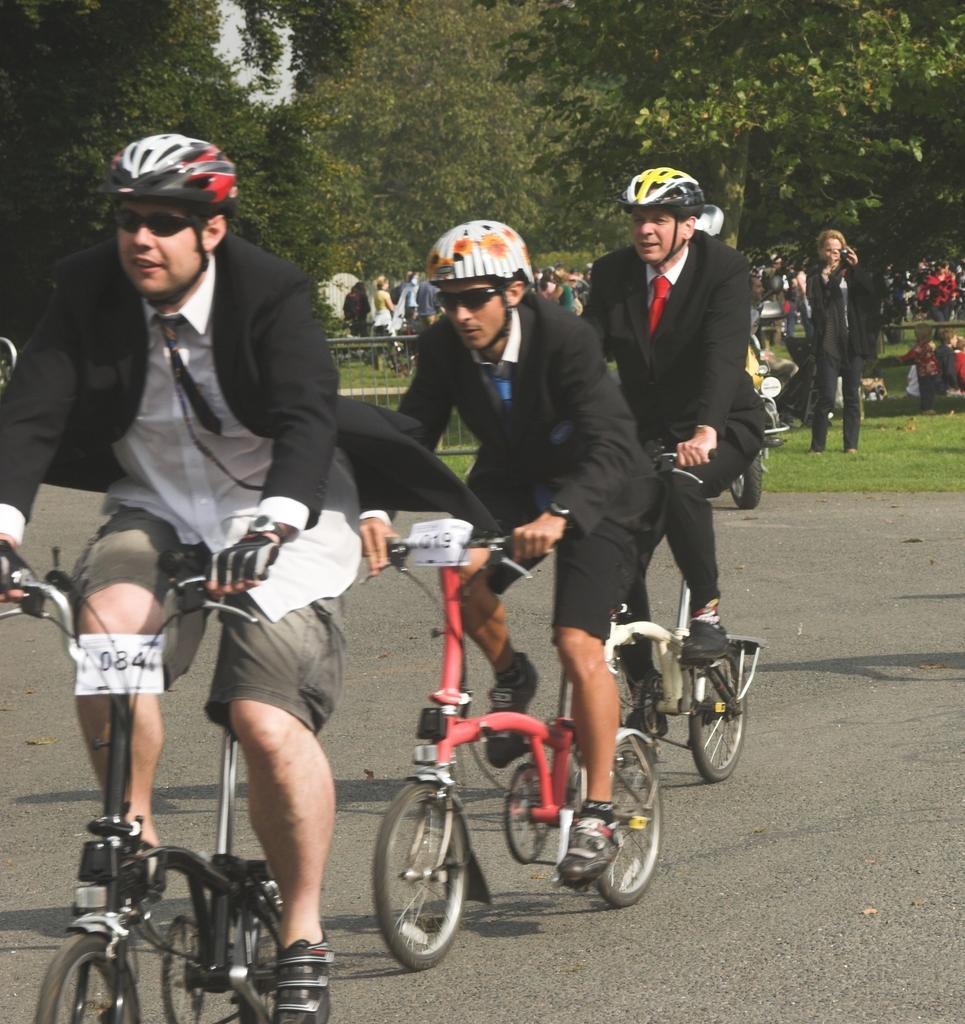Could you give a brief overview of what you see in this image? In this image I can see three persons riding the bicycles on the road by wearing black suit and helmets. In the background I can see some trees. On the right side of the image I can see a person standing and holding some device in hands. In the background there are number of people standing. 